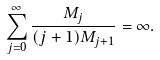<formula> <loc_0><loc_0><loc_500><loc_500>\sum _ { j = 0 } ^ { \infty } \frac { M _ { j } } { ( j + 1 ) M _ { j + 1 } } = \infty .</formula> 